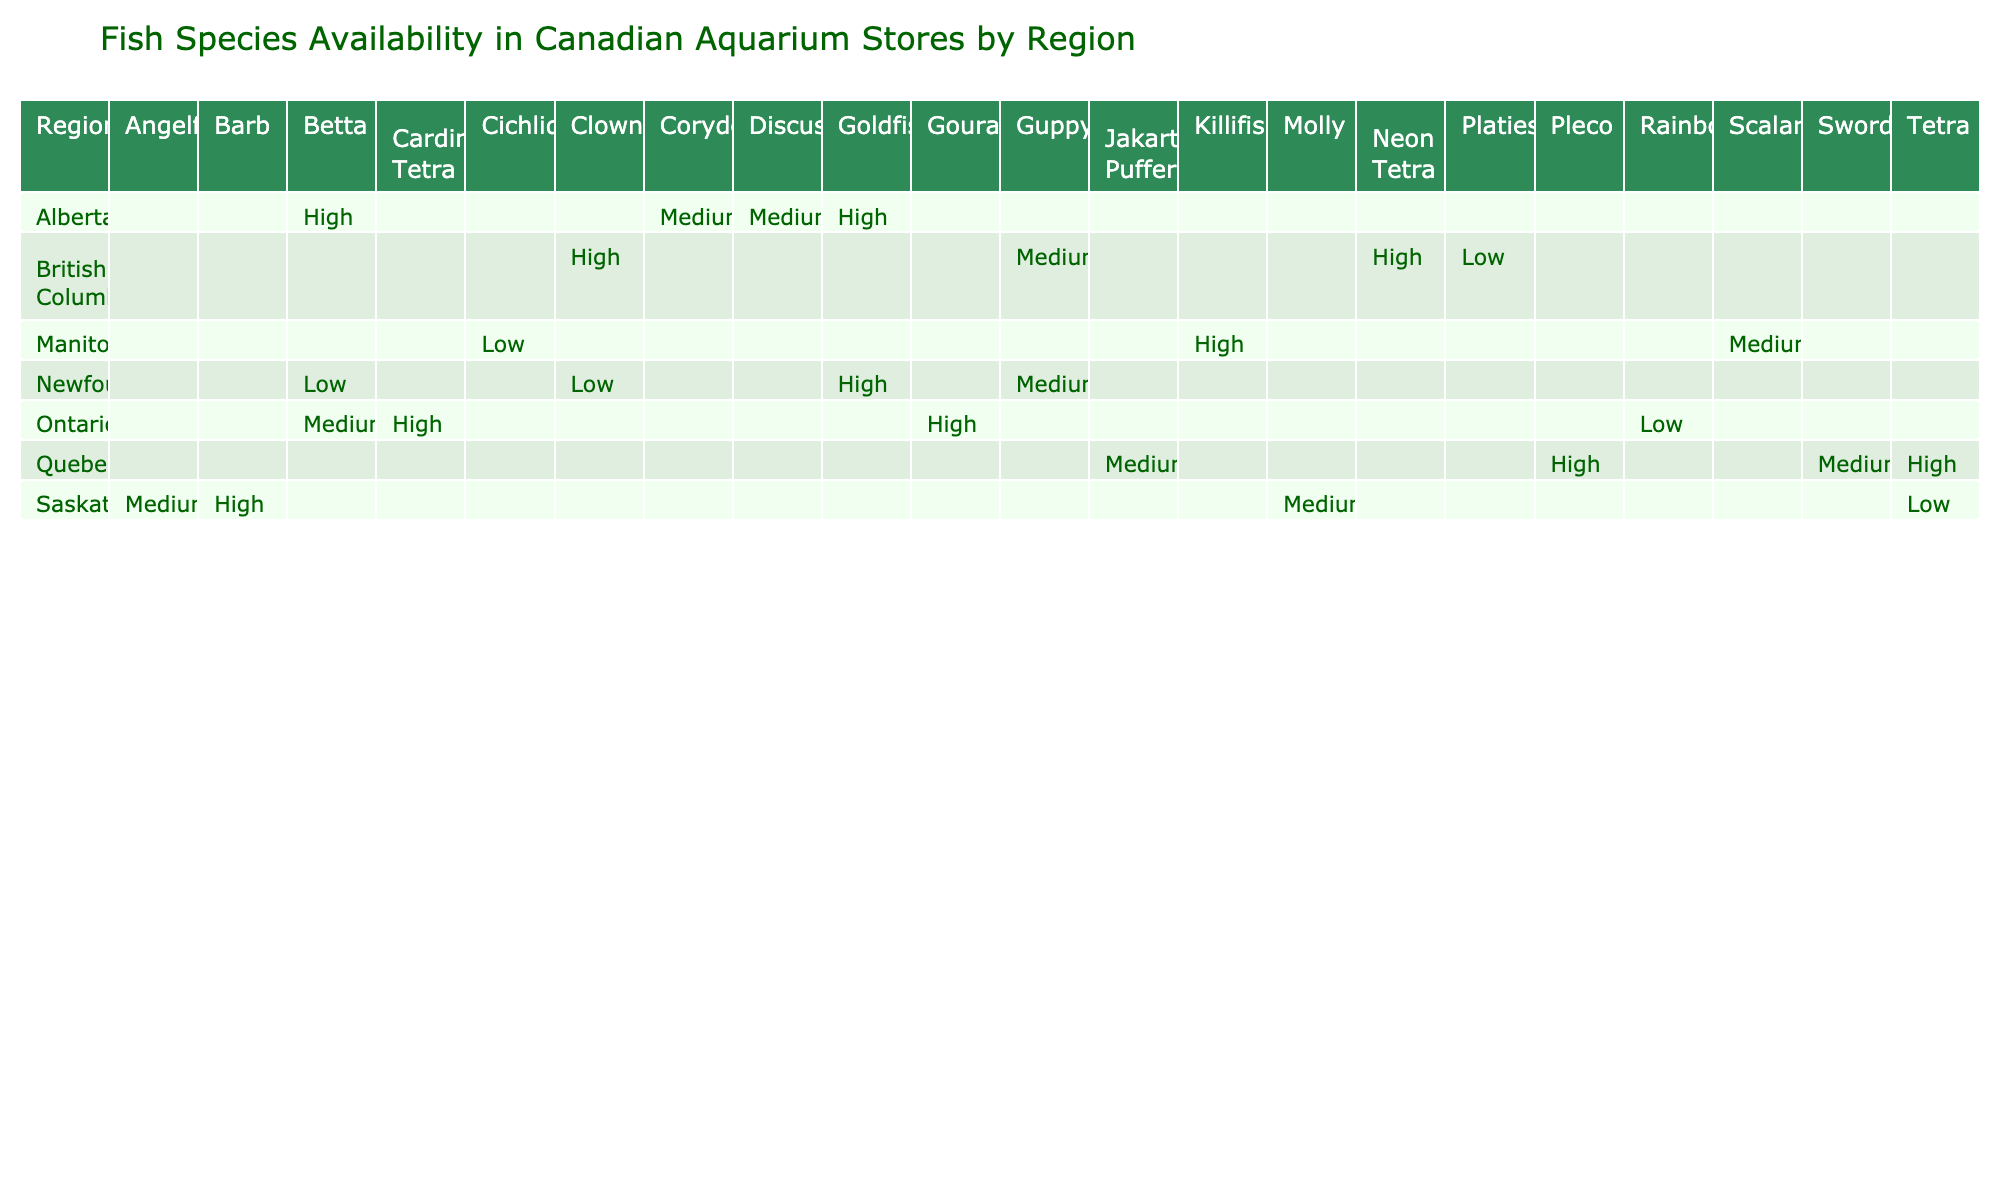What fish species has the highest availability in British Columbia? The table shows that the Clownfish and Neon Tetra have high availability in British Columbia, among all species listed for that region.
Answer: Clownfish and Neon Tetra Which region has the lowest availability for Betta? From the table, Newfoundland shows a low availability for Betta, while other regions have higher or medium availability.
Answer: Newfoundland How many species have low availability in Manitoba? In Manitoba, the table indicates that only one species, the Cichlid, has low availability. Thus, the answer is found directly by focusing on the region of Manitoba and counting the instances of low availability.
Answer: 1 Are there any species that have high availability in more than one region? Checking the table reveals multiple species with high availability across different regions: Clownfish and Neon Tetra in British Columbia, and Goldfish and Betta in Alberta. Therefore, the answer is yes, as these species appear in multiple regions with high availability.
Answer: Yes What is the difference in the count of species available at high versus low availability across all regions? By aggregating from the table, high availability species are: Clownfish, Neon Tetra, Discus, Betta, Goldfish, Barb, Cardinal Tetra, Gourami, Pleco, and Tetra, totaling 10 species. Low availability species include: Platies, Cichlid, Rainbowfish, Betta, Clownfish, and Tetra, totaling 6 species. The difference is 10 - 6 = 4 species.
Answer: 4 How many regions have species available at medium availability? Analyzing the table, we can see that Alberta, Saskatchewan, and Manitoba each have at least one species listed with medium availability. Counting these distinct regions reveals three.
Answer: 3 Which two species have high availability in Quebec? The table shows that in Quebec, both Pleco and Tetra have high availability. Thus, we can directly identify these species by looking for high availability listings under this region.
Answer: Pleco and Tetra Is there any fish species that is rare (low availability) in every region? By reviewing the table, there is no species that is consistently marked as low availability across all regions; each low availability species exists in a specific region.
Answer: No 